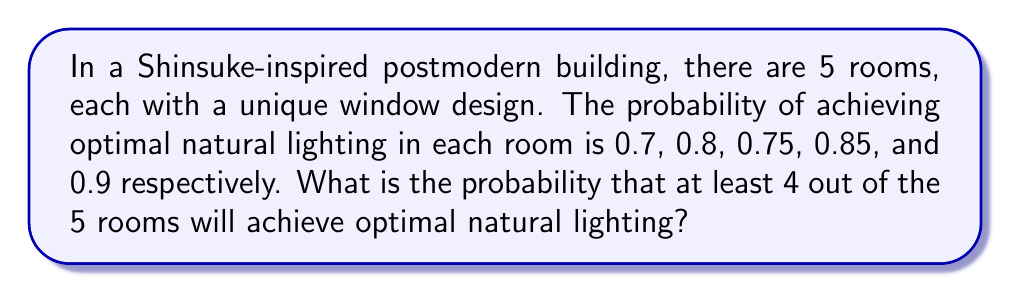Can you solve this math problem? Let's approach this step-by-step:

1) First, we need to calculate the probability of exactly 4 rooms achieving optimal lighting and the probability of all 5 rooms achieving optimal lighting.

2) The probability of exactly 4 rooms achieving optimal lighting:
   There are $\binom{5}{4} = 5$ ways to choose 4 rooms out of 5.
   
   For each combination:
   $P(\text{4 rooms optimal, 1 not}) = 0.7 \cdot 0.8 \cdot 0.75 \cdot 0.85 \cdot 0.1 + 0.7 \cdot 0.8 \cdot 0.75 \cdot 0.15 \cdot 0.9 + 0.7 \cdot 0.8 \cdot 0.25 \cdot 0.85 \cdot 0.9 + 0.7 \cdot 0.2 \cdot 0.75 \cdot 0.85 \cdot 0.9 + 0.3 \cdot 0.8 \cdot 0.75 \cdot 0.85 \cdot 0.9$

3) The probability of all 5 rooms achieving optimal lighting:
   $P(\text{all 5 optimal}) = 0.7 \cdot 0.8 \cdot 0.75 \cdot 0.85 \cdot 0.9$

4) Now, we add these probabilities:

   $P(\text{at least 4 optimal}) = P(\text{4 optimal}) + P(\text{5 optimal})$

   $= (0.7 \cdot 0.8 \cdot 0.75 \cdot 0.85 \cdot 0.1 + 0.7 \cdot 0.8 \cdot 0.75 \cdot 0.15 \cdot 0.9 + 0.7 \cdot 0.8 \cdot 0.25 \cdot 0.85 \cdot 0.9 + 0.7 \cdot 0.2 \cdot 0.75 \cdot 0.85 \cdot 0.9 + 0.3 \cdot 0.8 \cdot 0.75 \cdot 0.85 \cdot 0.9) + (0.7 \cdot 0.8 \cdot 0.75 \cdot 0.85 \cdot 0.9)$

5) Calculating this:
   $P(\text{at least 4 optimal}) \approx 0.7467$
Answer: $0.7467$ or $74.67\%$ 